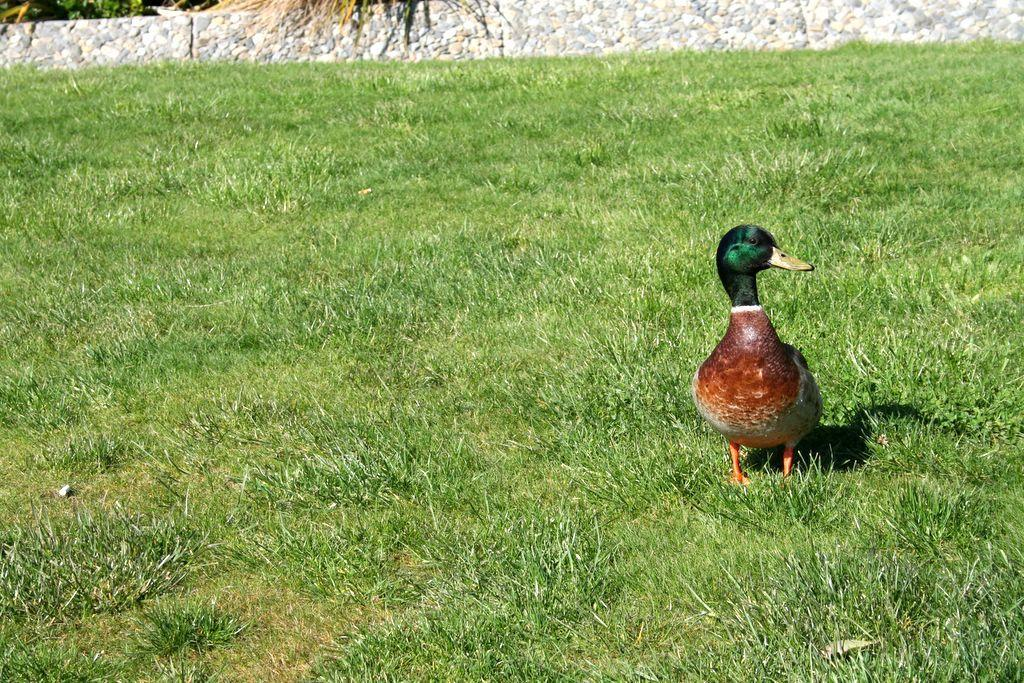What type of bird is on the ground in the image? There is a mallard on the ground in the image. What can be seen in the background of the image? There are stones arranged in a row in the background. What type of vegetation is on the ground? There is grass on the ground. What type of wristwatch is the mallard wearing in the image? The mallard is a bird and does not wear a wristwatch in the image. 